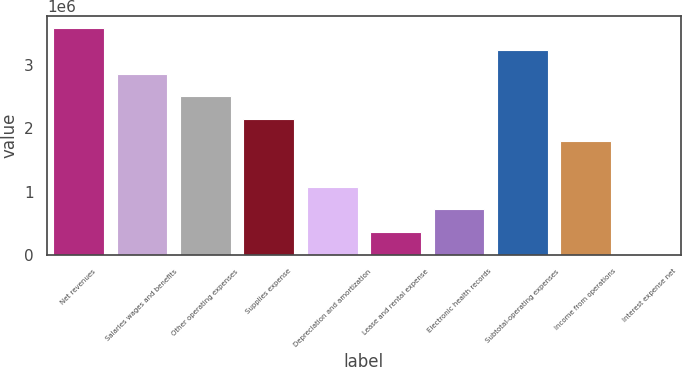<chart> <loc_0><loc_0><loc_500><loc_500><bar_chart><fcel>Net revenues<fcel>Salaries wages and benefits<fcel>Other operating expenses<fcel>Supplies expense<fcel>Depreciation and amortization<fcel>Lease and rental expense<fcel>Electronic health records<fcel>Subtotal-operating expenses<fcel>Income from operations<fcel>Interest expense net<nl><fcel>3.58686e+06<fcel>2.862e+06<fcel>2.50481e+06<fcel>2.14762e+06<fcel>1.07606e+06<fcel>361688<fcel>718875<fcel>3.22968e+06<fcel>1.79044e+06<fcel>4501<nl></chart> 